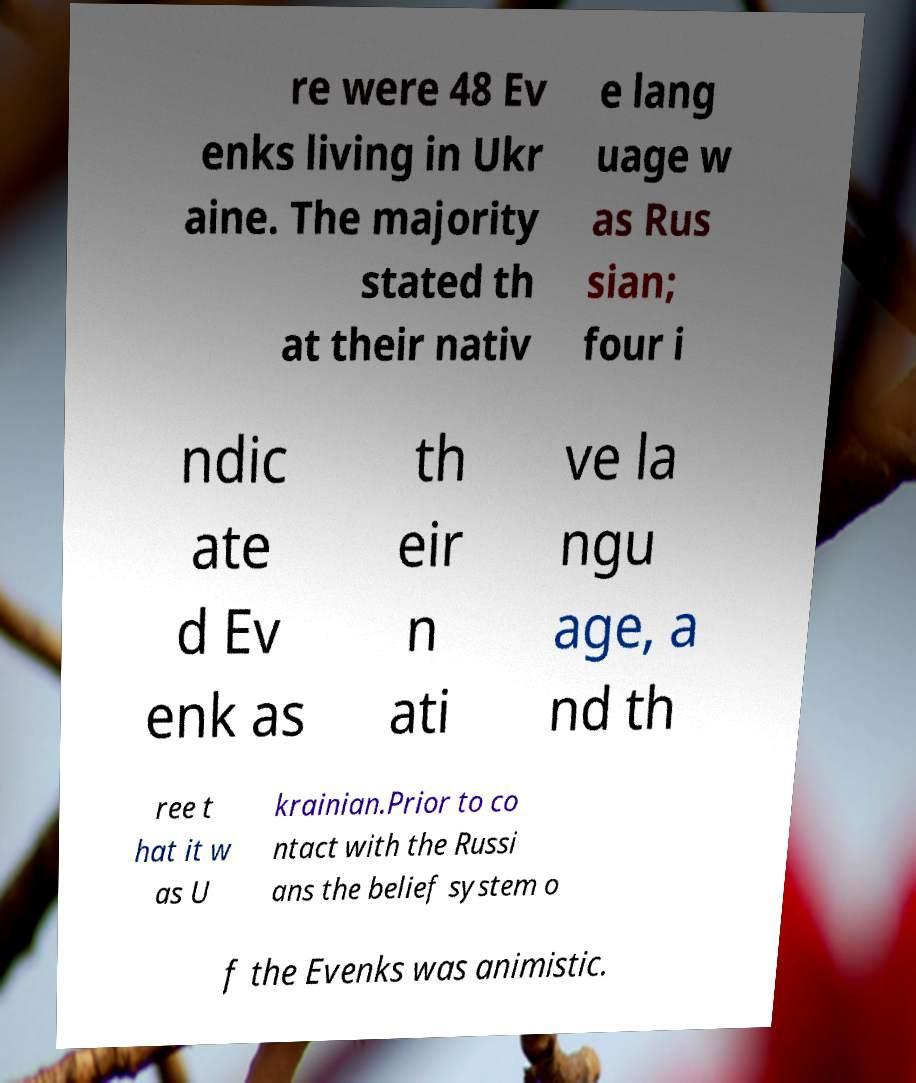For documentation purposes, I need the text within this image transcribed. Could you provide that? re were 48 Ev enks living in Ukr aine. The majority stated th at their nativ e lang uage w as Rus sian; four i ndic ate d Ev enk as th eir n ati ve la ngu age, a nd th ree t hat it w as U krainian.Prior to co ntact with the Russi ans the belief system o f the Evenks was animistic. 